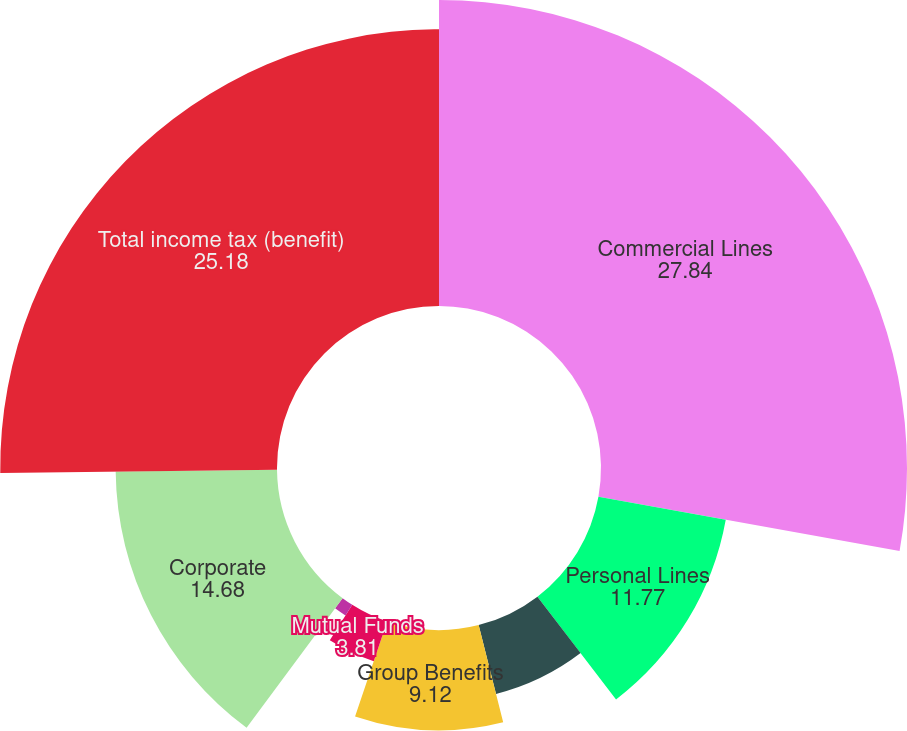Convert chart to OTSL. <chart><loc_0><loc_0><loc_500><loc_500><pie_chart><fcel>Commercial Lines<fcel>Personal Lines<fcel>Property & Casualty Other<fcel>Group Benefits<fcel>Mutual Funds<fcel>Talcott Resolution<fcel>Corporate<fcel>Total income tax (benefit)<nl><fcel>27.84%<fcel>11.77%<fcel>6.46%<fcel>9.12%<fcel>3.81%<fcel>1.15%<fcel>14.68%<fcel>25.18%<nl></chart> 